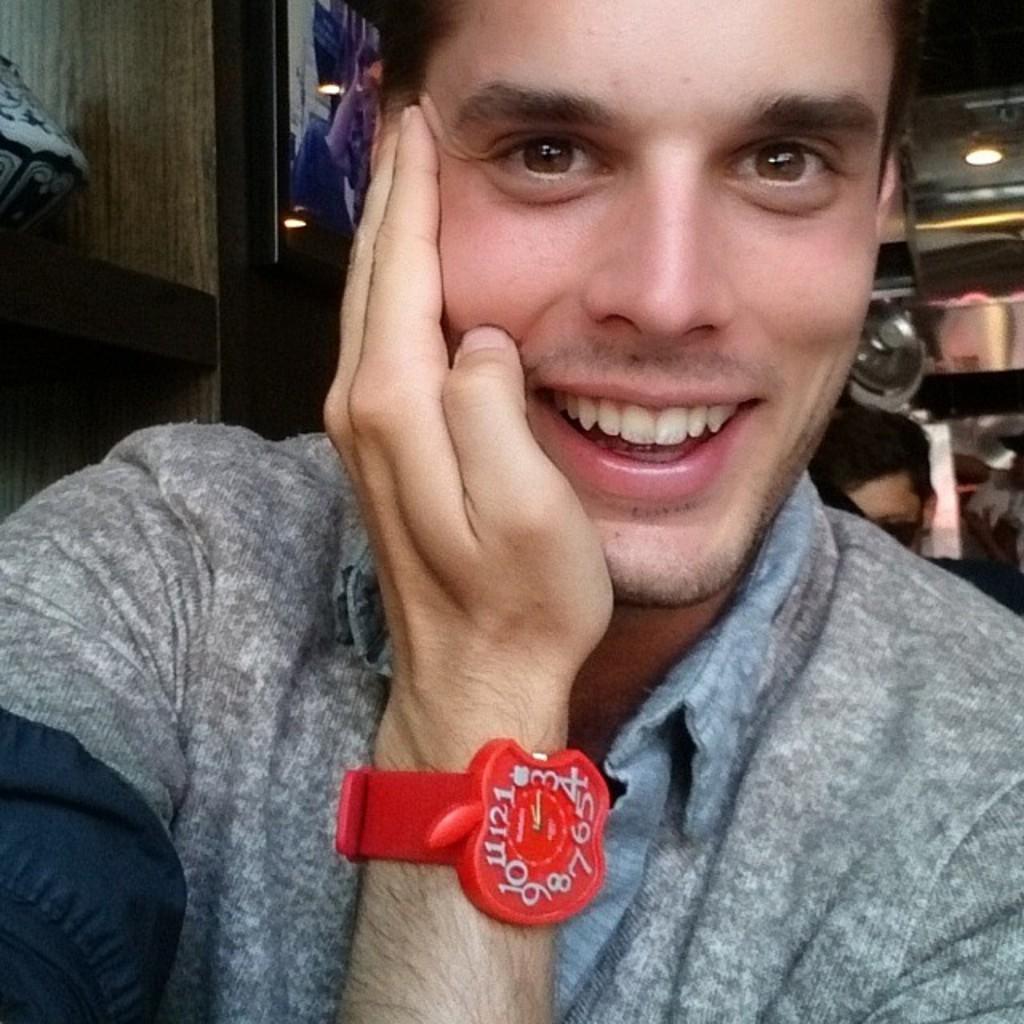In one or two sentences, can you explain what this image depicts? In this image, we can see a person wearing clothes and watch. There is a person head on the right side of the image. There is a light in the top right of the image. 